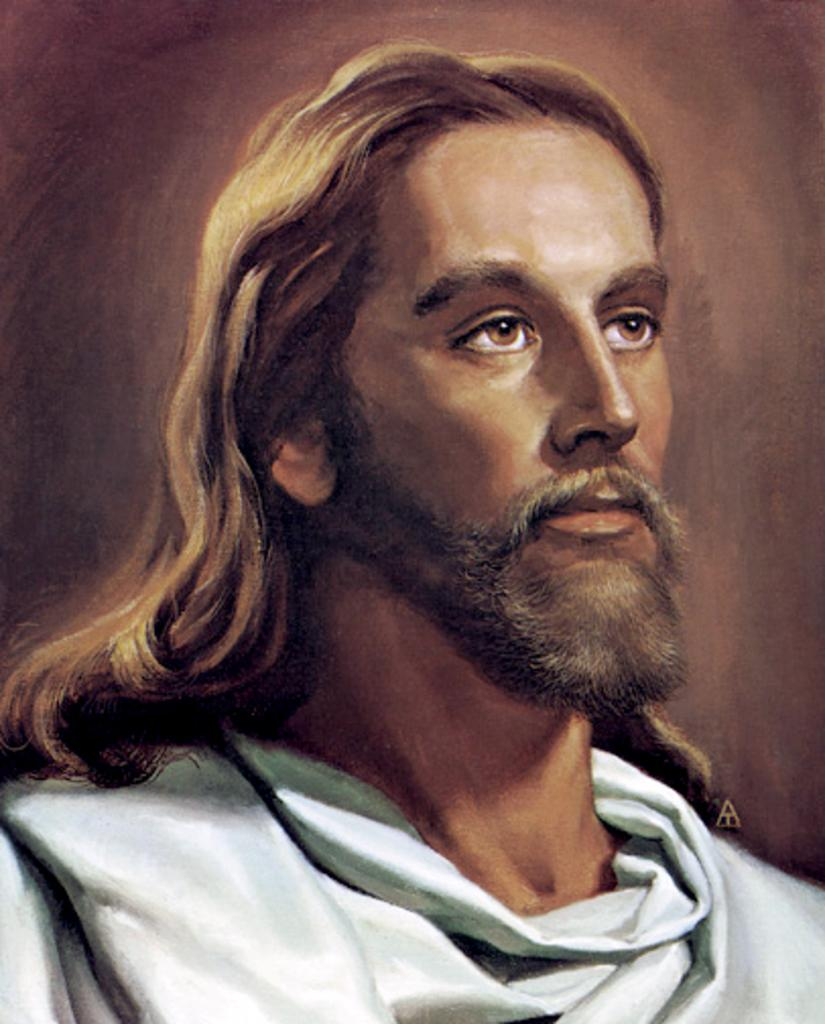What is the main subject of the image? There is a painting in the image. What does the painting depict? The painting depicts a person. What type of government is represented in the painting? There is no indication of a government in the painting, as it only depicts a person. How comfortable is the secretary in the painting? There is no secretary present in the painting, only a person. 